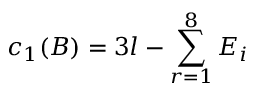<formula> <loc_0><loc_0><loc_500><loc_500>c _ { 1 } ( B ) = 3 l - \sum _ { r = 1 } ^ { 8 } E _ { i }</formula> 